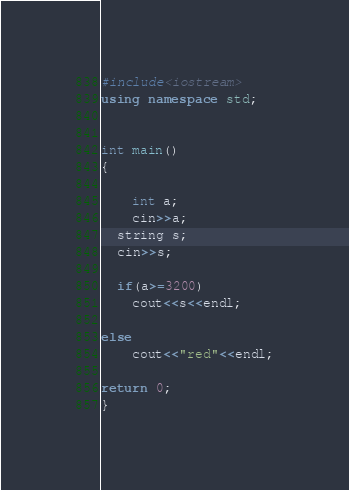Convert code to text. <code><loc_0><loc_0><loc_500><loc_500><_C++_>#include<iostream>
using namespace std;


int main()
{

    int a;
    cin>>a;
  string s;
  cin>>s;

  if(a>=3200)
    cout<<s<<endl;

else
    cout<<"red"<<endl;

return 0;
}</code> 